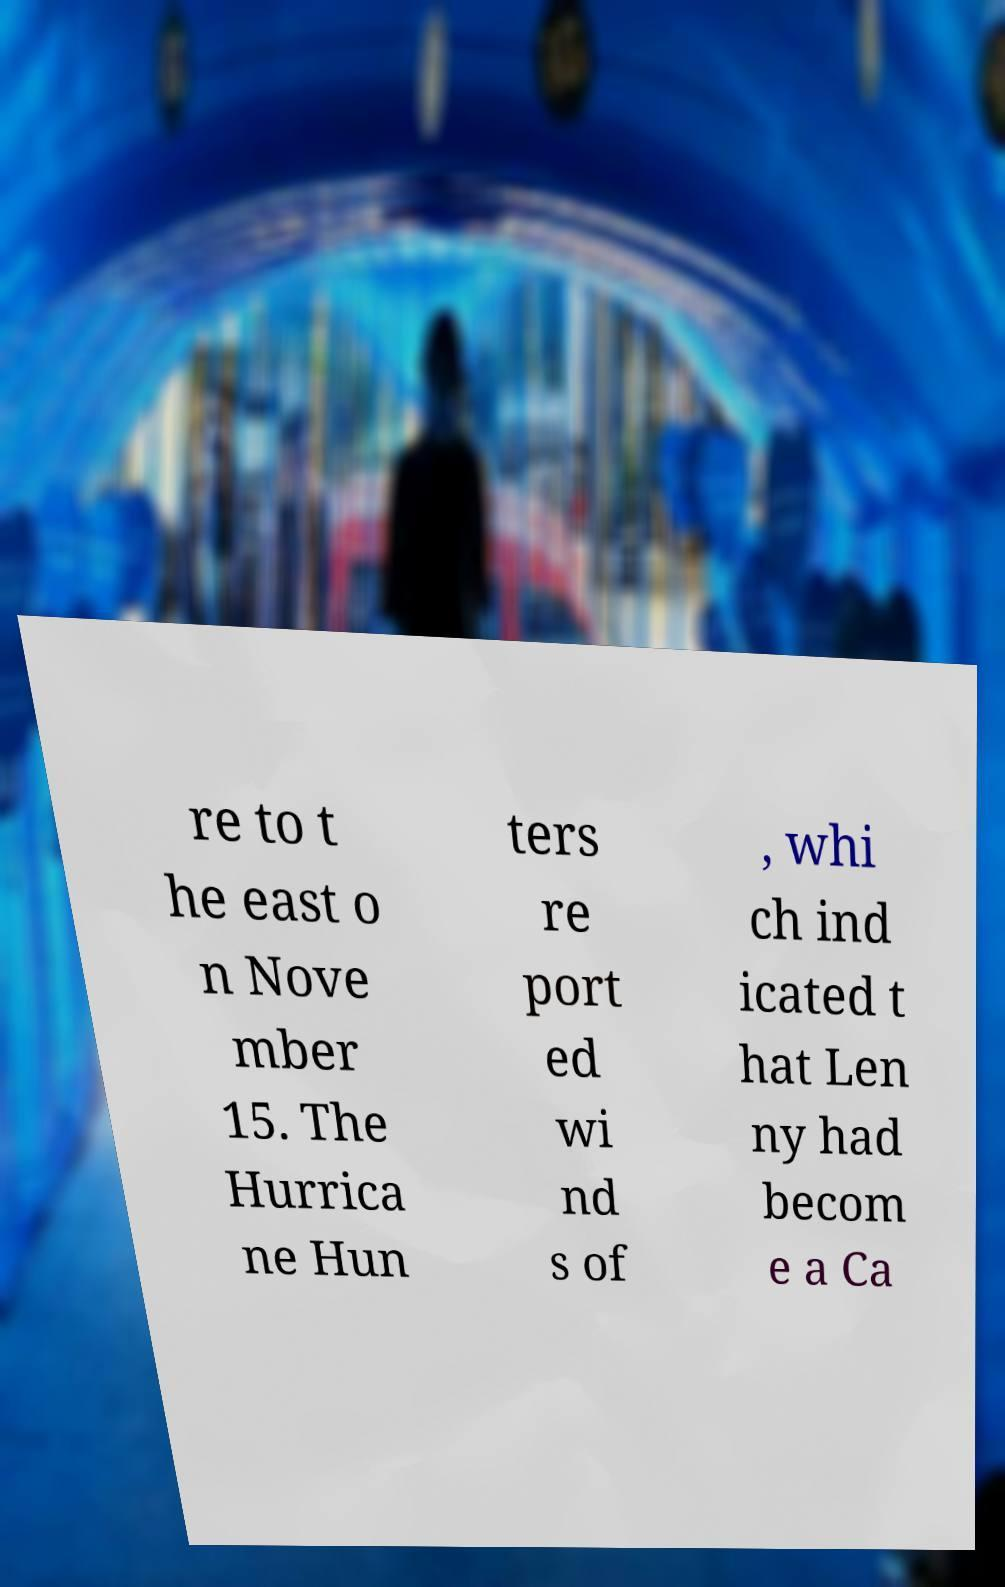What messages or text are displayed in this image? I need them in a readable, typed format. re to t he east o n Nove mber 15. The Hurrica ne Hun ters re port ed wi nd s of , whi ch ind icated t hat Len ny had becom e a Ca 